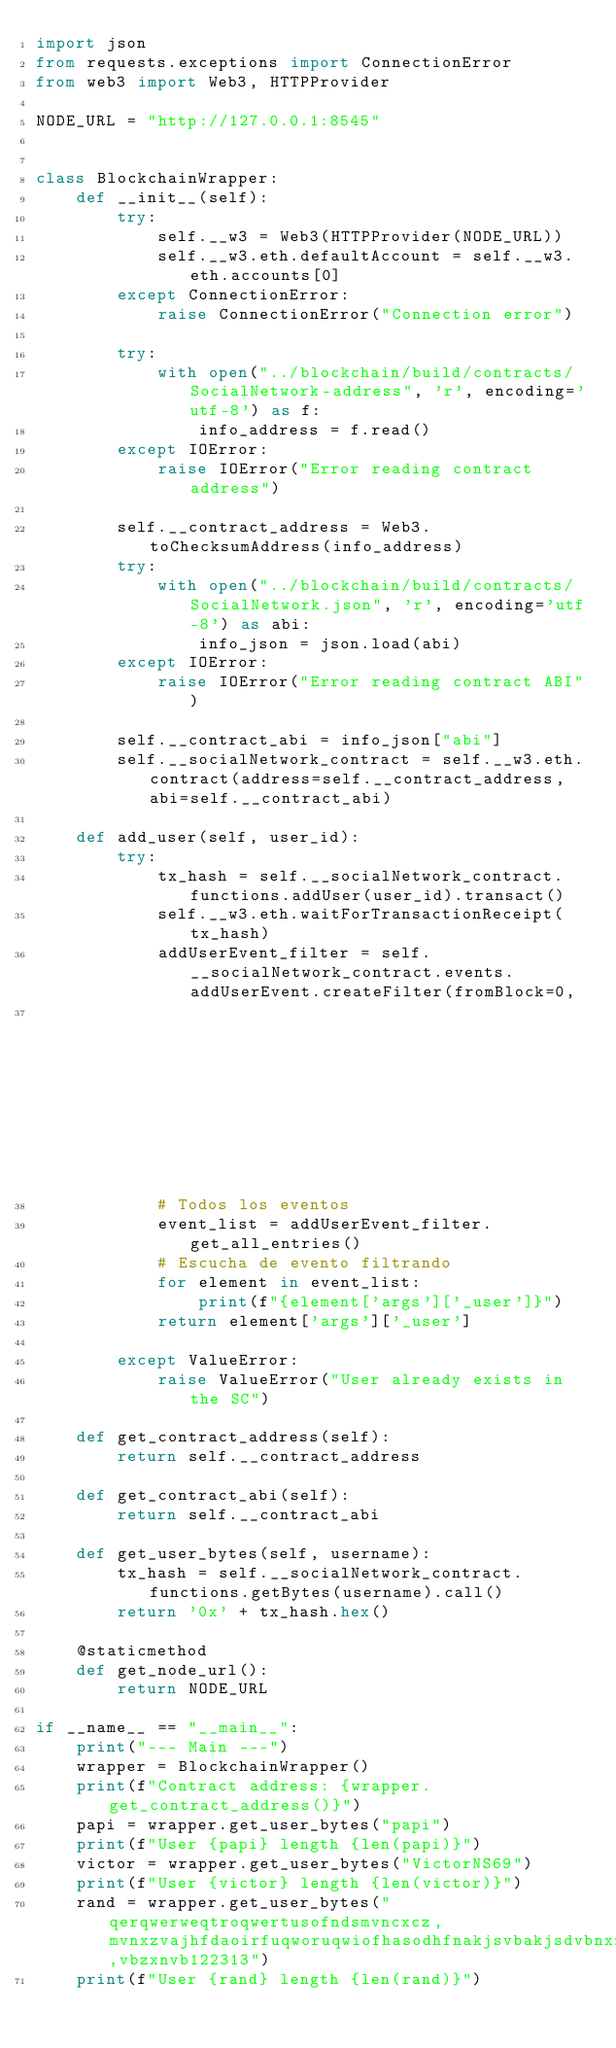<code> <loc_0><loc_0><loc_500><loc_500><_Python_>import json
from requests.exceptions import ConnectionError
from web3 import Web3, HTTPProvider

NODE_URL = "http://127.0.0.1:8545"


class BlockchainWrapper:
    def __init__(self):
        try:
            self.__w3 = Web3(HTTPProvider(NODE_URL))
            self.__w3.eth.defaultAccount = self.__w3.eth.accounts[0]
        except ConnectionError:
            raise ConnectionError("Connection error")

        try:
            with open("../blockchain/build/contracts/SocialNetwork-address", 'r', encoding='utf-8') as f:
                info_address = f.read()
        except IOError:
            raise IOError("Error reading contract address")

        self.__contract_address = Web3.toChecksumAddress(info_address)
        try:
            with open("../blockchain/build/contracts/SocialNetwork.json", 'r', encoding='utf-8') as abi:
                info_json = json.load(abi)
        except IOError:
            raise IOError("Error reading contract ABI")

        self.__contract_abi = info_json["abi"]
        self.__socialNetwork_contract = self.__w3.eth.contract(address=self.__contract_address, abi=self.__contract_abi)

    def add_user(self, user_id):
        try:
            tx_hash = self.__socialNetwork_contract.functions.addUser(user_id).transact()
            self.__w3.eth.waitForTransactionReceipt(tx_hash)
            addUserEvent_filter = self.__socialNetwork_contract.events.addUserEvent.createFilter(fromBlock=0,
                                                                                  argument_filters={'_user': user_id})
            # Todos los eventos
            event_list = addUserEvent_filter.get_all_entries()
            # Escucha de evento filtrando
            for element in event_list:
                print(f"{element['args']['_user']}")
            return element['args']['_user']

        except ValueError:
            raise ValueError("User already exists in the SC")

    def get_contract_address(self):
        return self.__contract_address

    def get_contract_abi(self):
        return self.__contract_abi

    def get_user_bytes(self, username):
        tx_hash = self.__socialNetwork_contract.functions.getBytes(username).call()
        return '0x' + tx_hash.hex()

    @staticmethod
    def get_node_url():
        return NODE_URL

if __name__ == "__main__":
    print("--- Main ---")
    wrapper = BlockchainWrapper()
    print(f"Contract address: {wrapper.get_contract_address()}")
    papi = wrapper.get_user_bytes("papi")
    print(f"User {papi} length {len(papi)}")
    victor = wrapper.get_user_bytes("VictorNS69")
    print(f"User {victor} length {len(victor)}")
    rand = wrapper.get_user_bytes("qerqwerweqtroqwertusofndsmvncxcz,mvnxzvajhfdaoirfuqworuqwiofhasodhfnakjsvbakjsdvbnxzc,vbzxnvb122313")
    print(f"User {rand} length {len(rand)}")</code> 